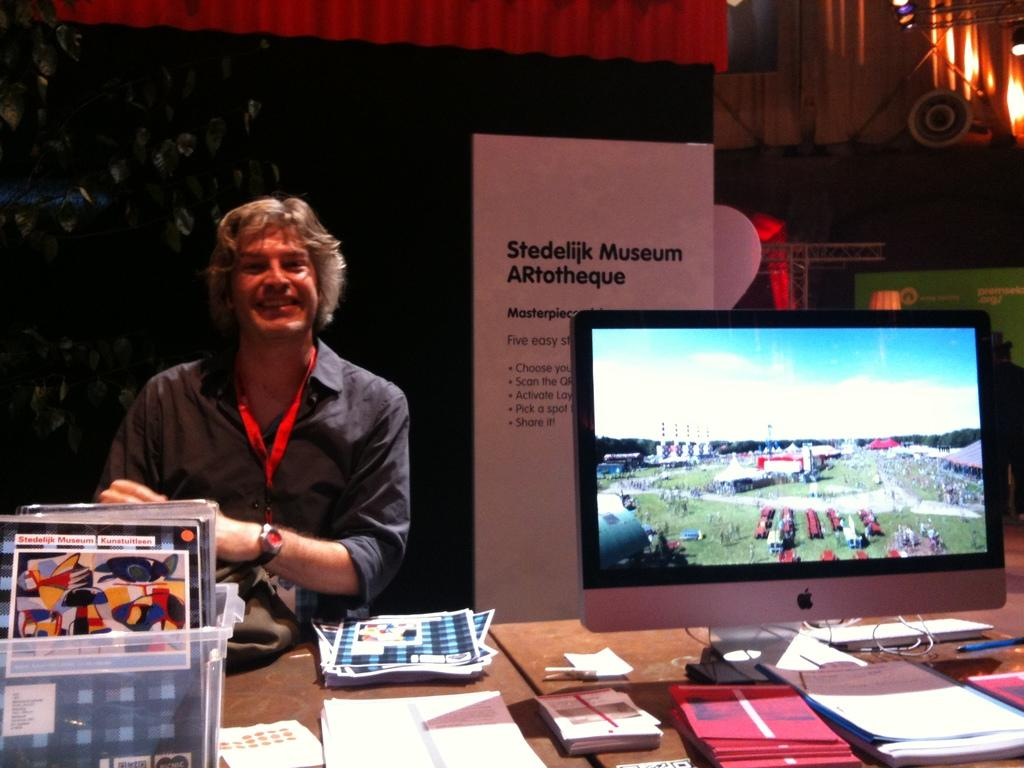<image>
Provide a brief description of the given image. The last of the five easy steps is to Share It 